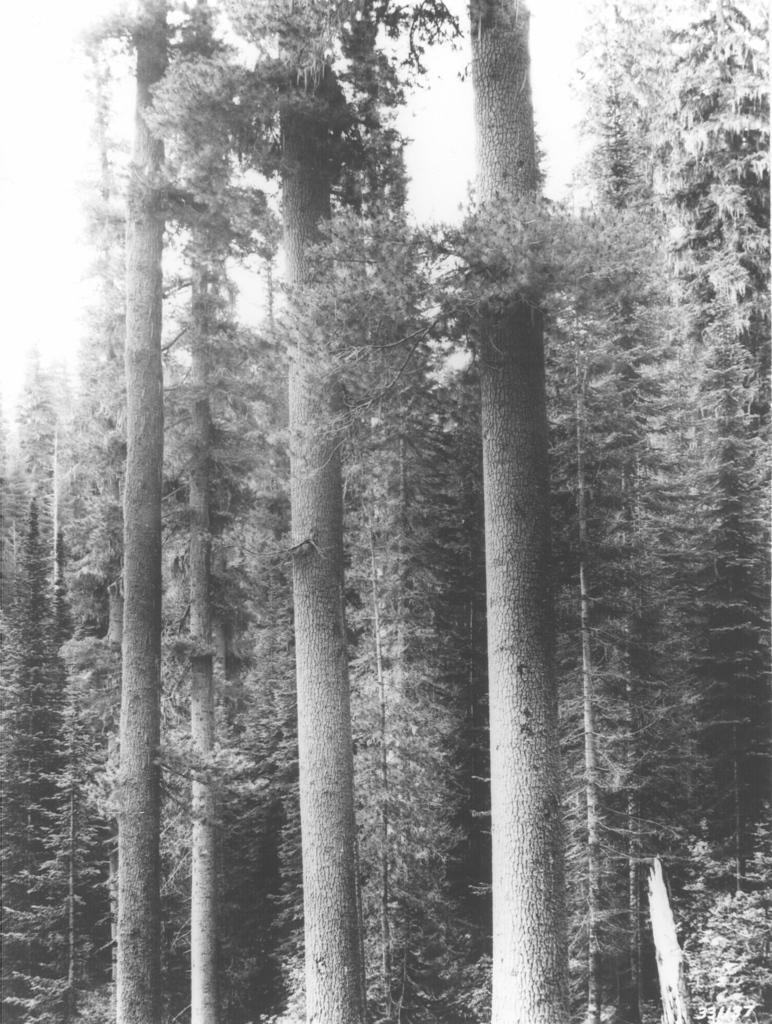Describe this image in one or two sentences. This image consists of many trees. 